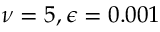<formula> <loc_0><loc_0><loc_500><loc_500>\nu = 5 , \epsilon = 0 . 0 0 1</formula> 